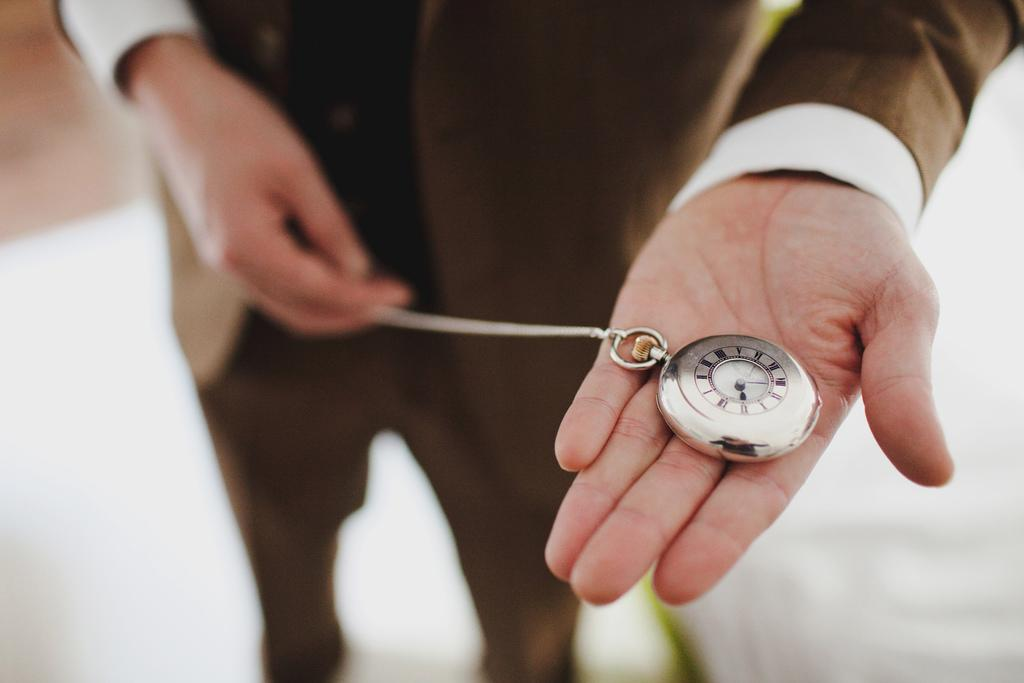What object is being held by a person in the image? There is a clock chain in the person's hand in the image. Can you describe the object being held? The object is a clock chain. What type of skin is visible on the clock chain in the image? There is no skin visible on the clock chain in the image, as it is an inanimate object. 